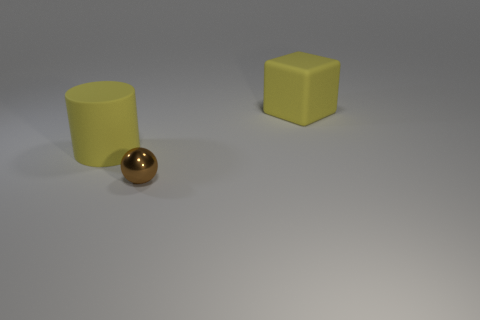Is there any other thing that has the same material as the tiny brown thing?
Make the answer very short. No. What is the shape of the big yellow matte object that is behind the big yellow thing left of the yellow rubber block?
Your answer should be very brief. Cube. There is a block that is the same color as the big cylinder; what is it made of?
Offer a terse response. Rubber. What color is the cube that is made of the same material as the yellow cylinder?
Provide a short and direct response. Yellow. Is there any other thing that has the same size as the ball?
Offer a terse response. No. There is a large rubber object in front of the cube; is it the same color as the big thing on the right side of the rubber cylinder?
Keep it short and to the point. Yes. Are there more big cubes that are behind the tiny brown shiny thing than yellow rubber cubes that are to the right of the rubber cube?
Your answer should be very brief. Yes. Is there any other thing that is the same shape as the brown shiny object?
Keep it short and to the point. No. Do the tiny object and the big yellow object that is on the right side of the tiny brown thing have the same shape?
Offer a terse response. No. What number of other things are the same material as the small ball?
Provide a succinct answer. 0. 